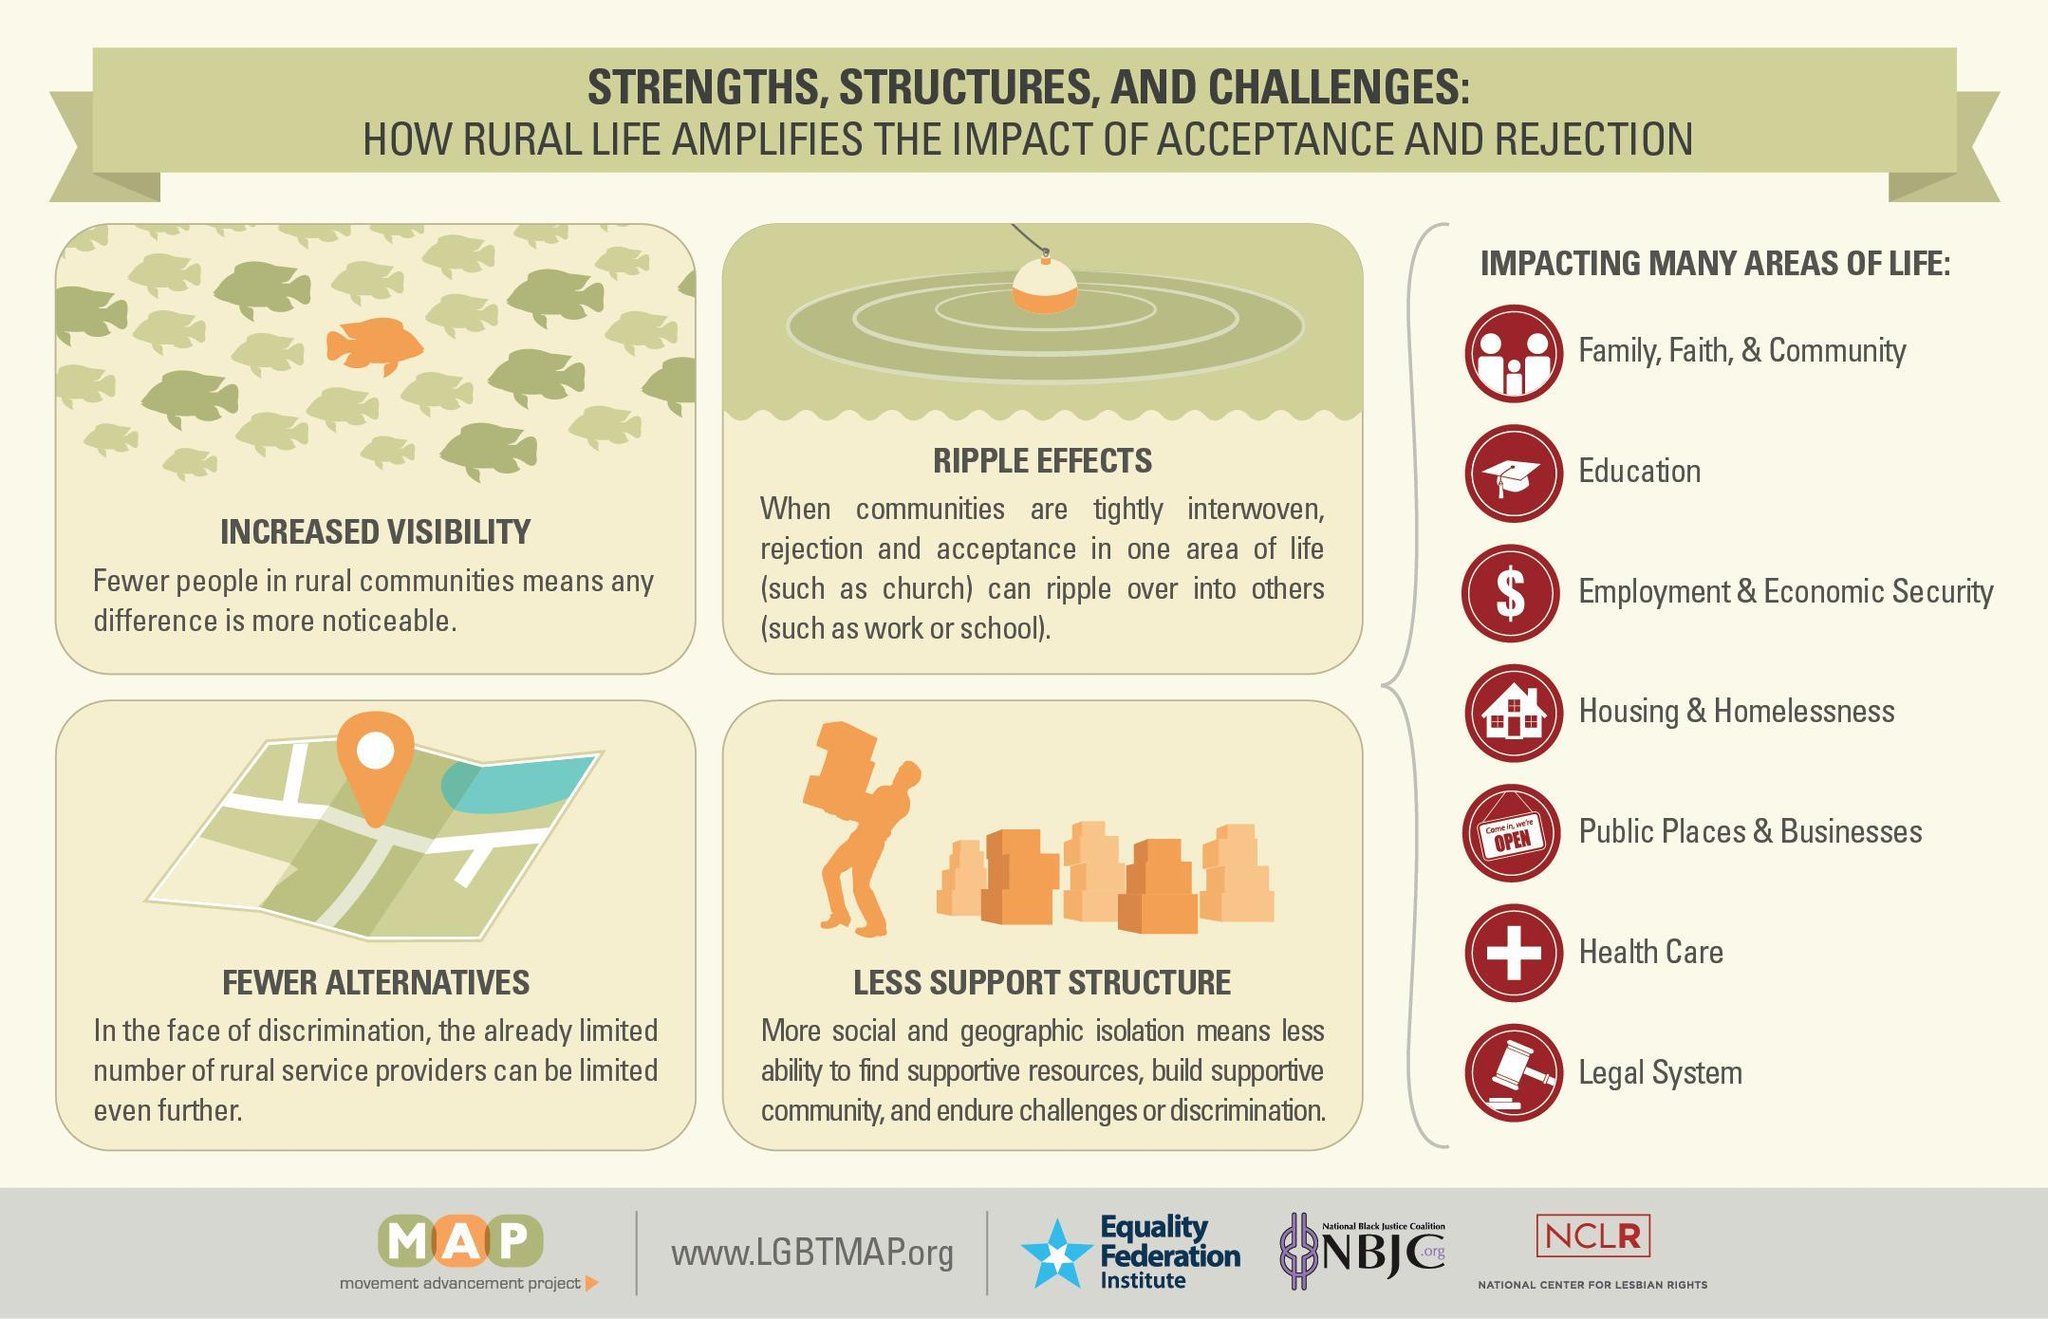How many impacting areas of life are listed?
Answer the question with a short phrase. 7 